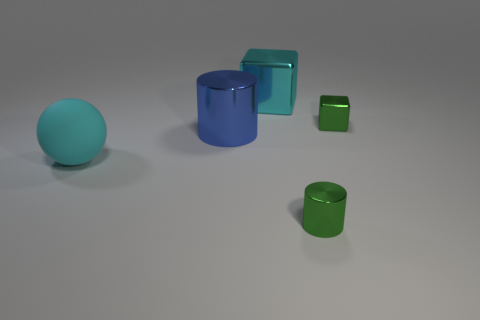Add 1 brown balls. How many objects exist? 6 Subtract all cylinders. How many objects are left? 3 Add 4 large blue metallic cylinders. How many large blue metallic cylinders exist? 5 Subtract 1 blue cylinders. How many objects are left? 4 Subtract all small shiny things. Subtract all tiny green metal blocks. How many objects are left? 2 Add 2 cyan rubber things. How many cyan rubber things are left? 3 